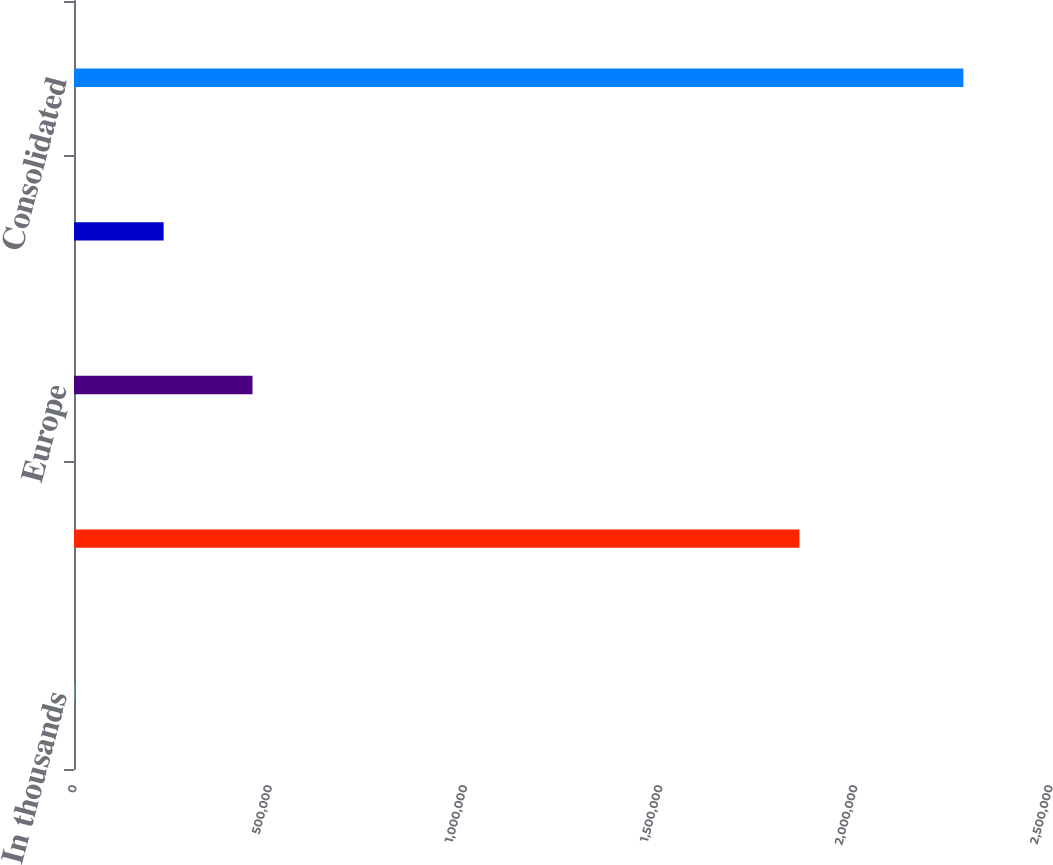<chart> <loc_0><loc_0><loc_500><loc_500><bar_chart><fcel>In thousands<fcel>US/Canada<fcel>Europe<fcel>Asia and other<fcel>Consolidated<nl><fcel>2004<fcel>1.85822e+06<fcel>457229<fcel>229616<fcel>2.27813e+06<nl></chart> 